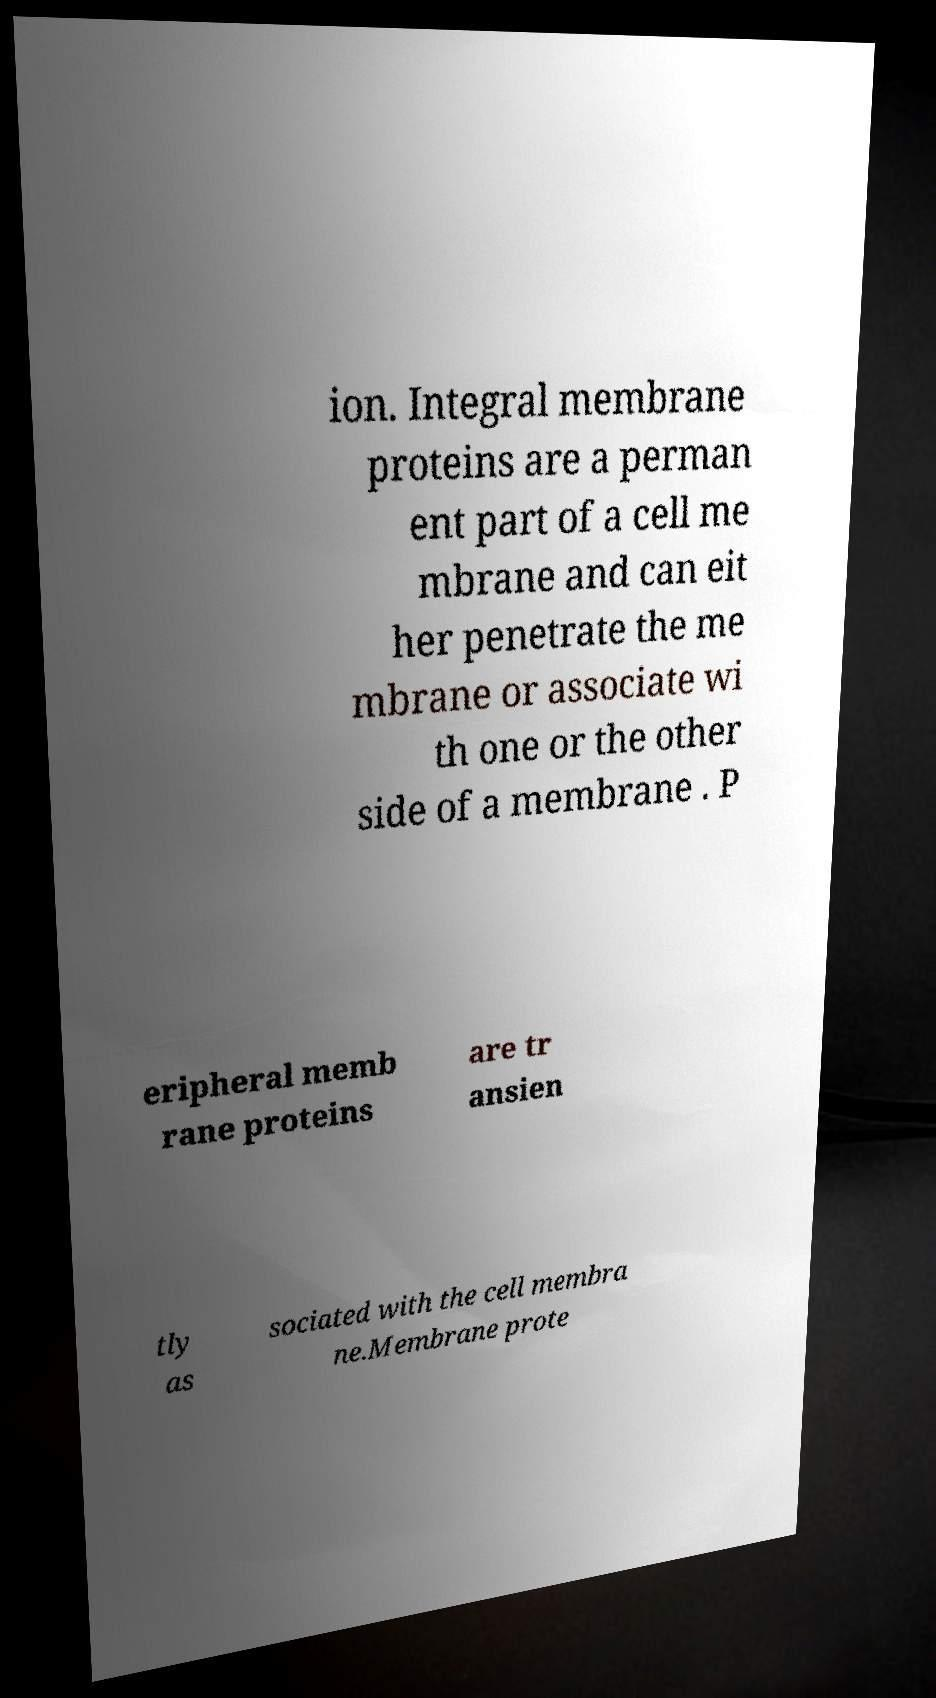For documentation purposes, I need the text within this image transcribed. Could you provide that? ion. Integral membrane proteins are a perman ent part of a cell me mbrane and can eit her penetrate the me mbrane or associate wi th one or the other side of a membrane . P eripheral memb rane proteins are tr ansien tly as sociated with the cell membra ne.Membrane prote 